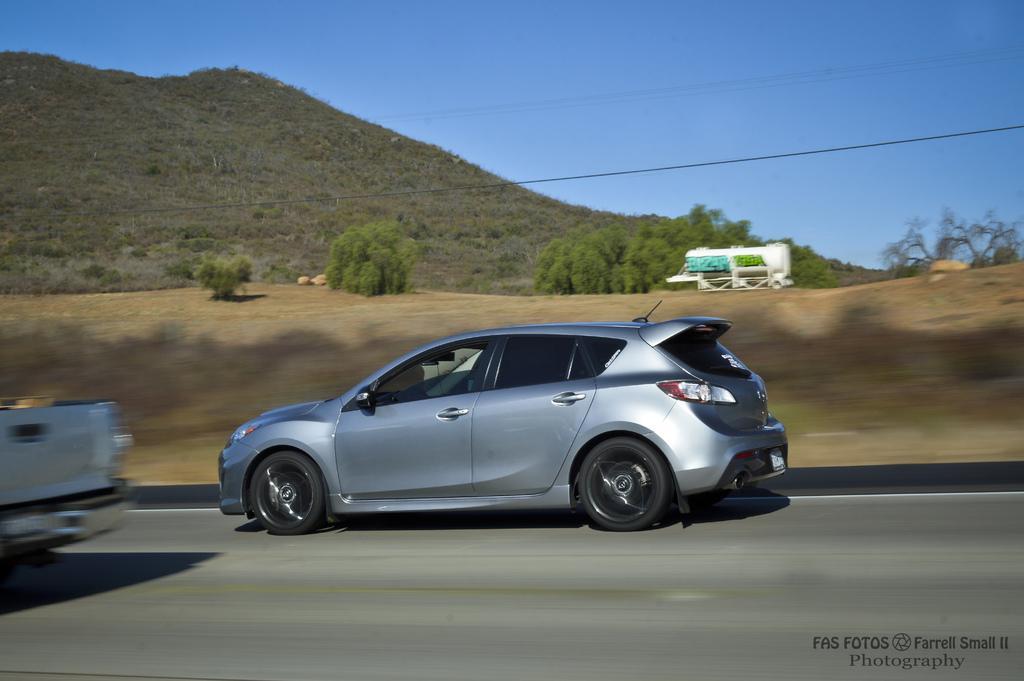Can you describe this image briefly? In the image there is a car and behind the car there are few trees and a mountain, the picture is captured while the vehicle is in motion. 